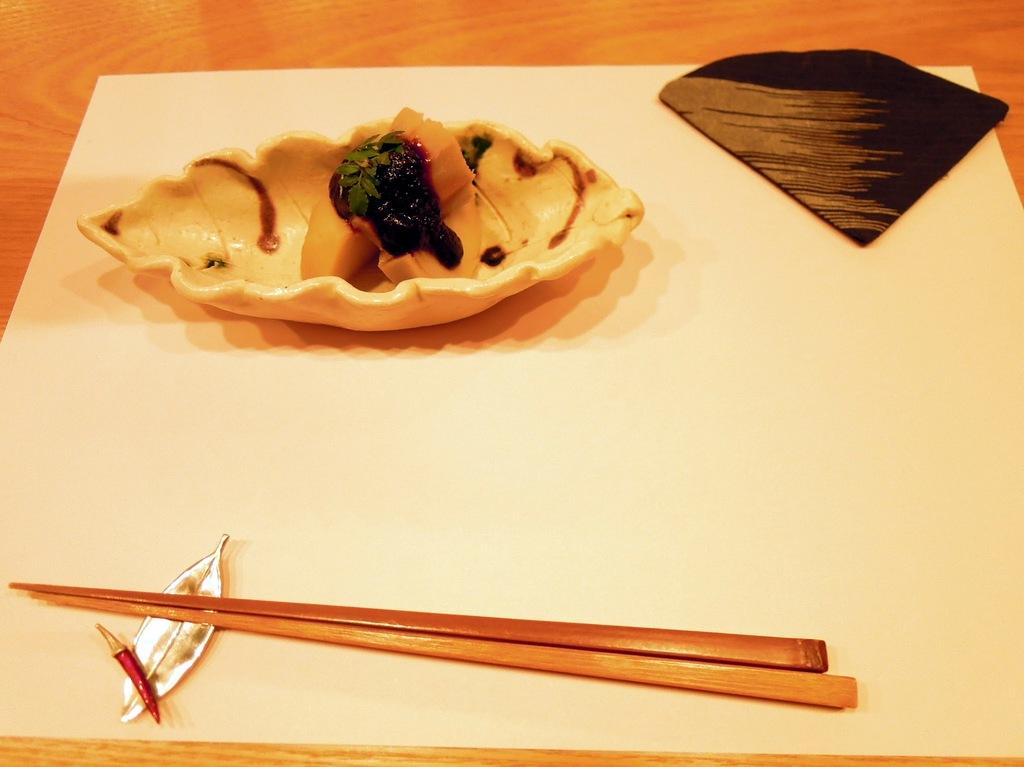What utensils are present in the image? There are chopsticks in the image. What is on the plate in the image? There is food in a plate in the image. What type of corn is being played by the band in the image? There is no corn or band present in the image; it only features chopsticks and food on a plate. 